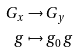Convert formula to latex. <formula><loc_0><loc_0><loc_500><loc_500>G _ { x } & \to G _ { y } \\ g & \mapsto g _ { 0 } \, g</formula> 